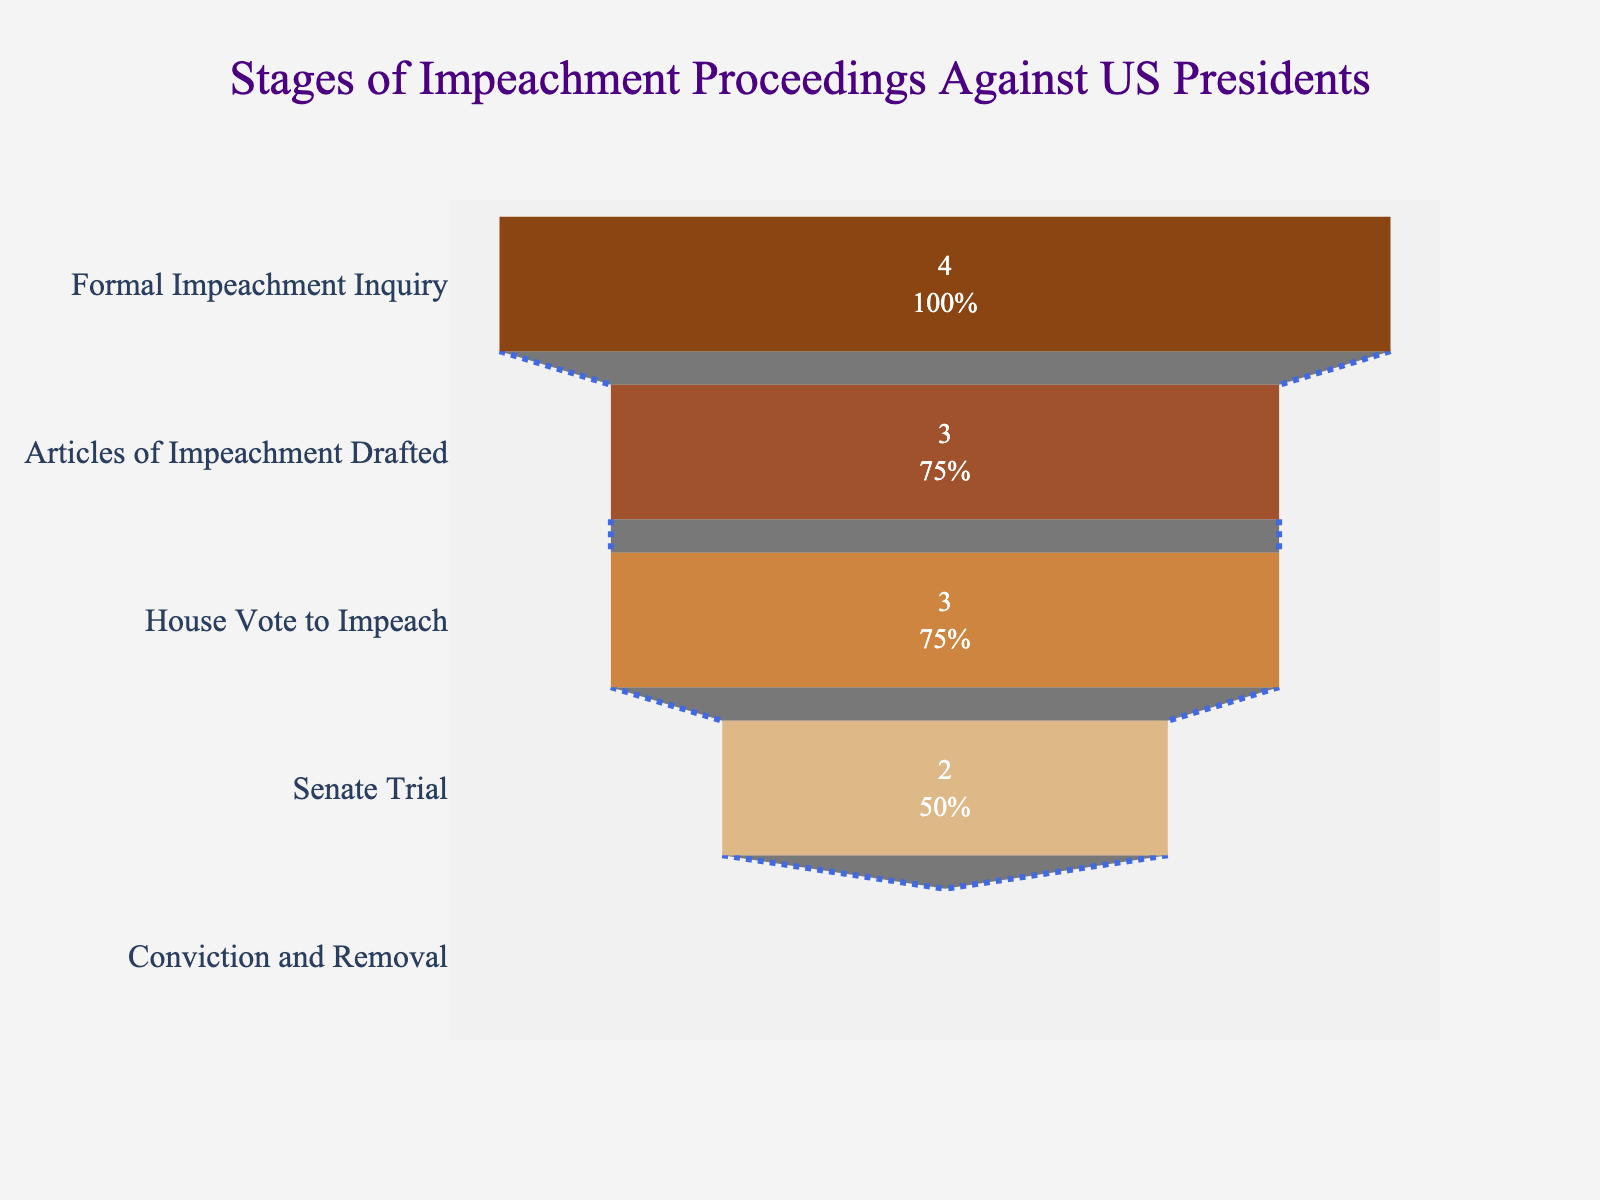what is the title of the plot? The title of the plot is usually displayed at the top of the chart. In this case, it is indicated by the text that appears prominently at the top of the visual.
Answer: Stages of Impeachment Proceedings Against US Presidents How many stages result in no cases? You can determine the number of stages that result in zero cases by looking at the values associated with each stage.
Answer: 1 Which stage has the highest number of cases? To answer this, locate the stage with the maximum value in the visualization.
Answer: Formal Impeachment Inquiry Compare the number of cases at "Articles of Impeachment Drafted" and "Senate Trial." Which one has more cases? Identify the values for both stages and compare them to determine which has more cases.
Answer: Articles of Impeachment Drafted What percentage of initial cases reach the "Senate Trial" stage? First, identify the number of cases at the "Formal Impeachment Inquiry" stage and the "Senate Trial" stage. Then calculate the percentage as (Senate Trial cases / Formal Impeachment Inquiry cases) * 100%.
Answer: 50% What color is used to represent the "Conviction and Removal" stage? You can determine the color of each stage by examining the markers in the visualization.
Answer: Light brown What is the difference in the number of cases between the "House Vote to Impeach" and the "Senate Trial" stages? Subtract the number of cases in the "Senate Trial" stage from the number of cases in the "House Vote to Impeach" stage to find the difference.
Answer: 1 Which stage appears directly before "Senate Trial"? Identify the sequence of stages in the funnel chart and find the one that precedes the "Senate Trial" stage.
Answer: House Vote to Impeach How many total cases are there after subtracting cases that did not advance from each stage? Starting with the initial number of cases, subtract the cases lost at each stage sequentially: 4 (initial) - (4-3) - (3-3) - (3-2) - (2-0).
Answer: 0 How does the text inside the chart provide information about the stages? The text inside the chart offers numerical values and percentages about how many cases reached each stage and what those values represent out of the initial amount.
Answer: Value + Percentage 